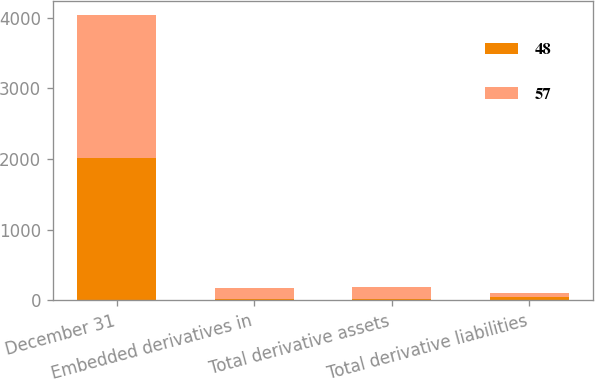Convert chart. <chart><loc_0><loc_0><loc_500><loc_500><stacked_bar_chart><ecel><fcel>December 31<fcel>Embedded derivatives in<fcel>Total derivative assets<fcel>Total derivative liabilities<nl><fcel>48<fcel>2018<fcel>23<fcel>23<fcel>48<nl><fcel>57<fcel>2017<fcel>155<fcel>167<fcel>57<nl></chart> 